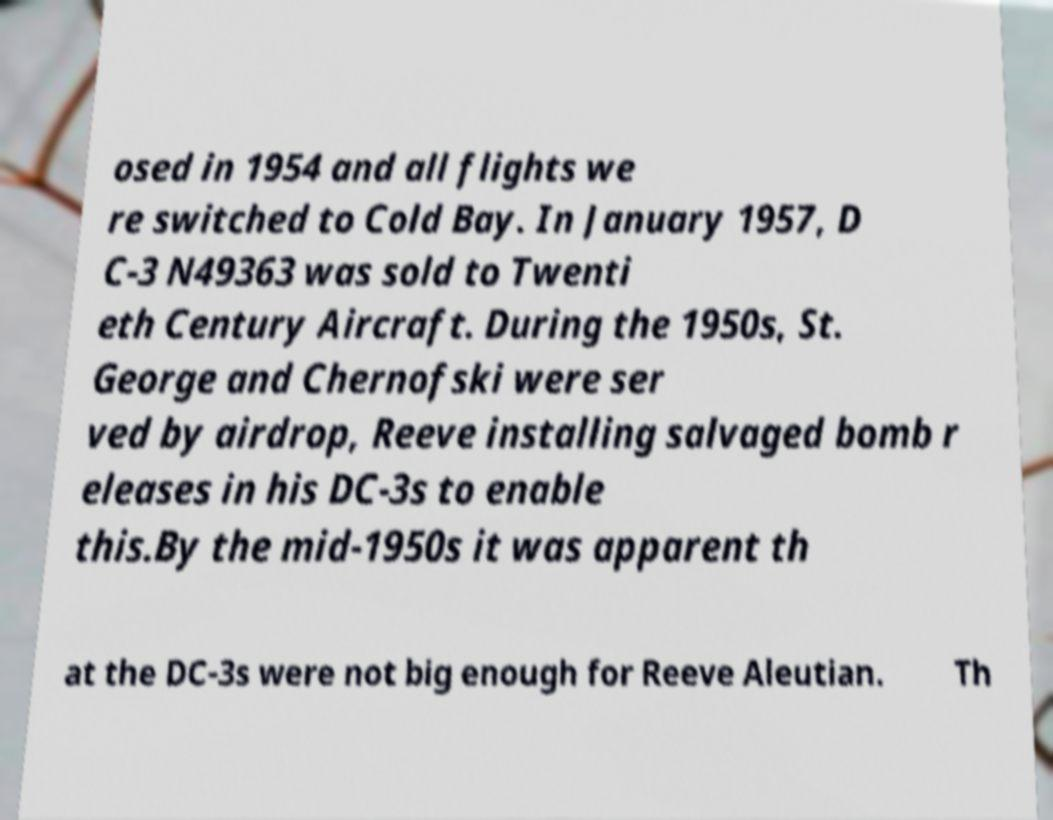Can you accurately transcribe the text from the provided image for me? osed in 1954 and all flights we re switched to Cold Bay. In January 1957, D C-3 N49363 was sold to Twenti eth Century Aircraft. During the 1950s, St. George and Chernofski were ser ved by airdrop, Reeve installing salvaged bomb r eleases in his DC-3s to enable this.By the mid-1950s it was apparent th at the DC-3s were not big enough for Reeve Aleutian. Th 